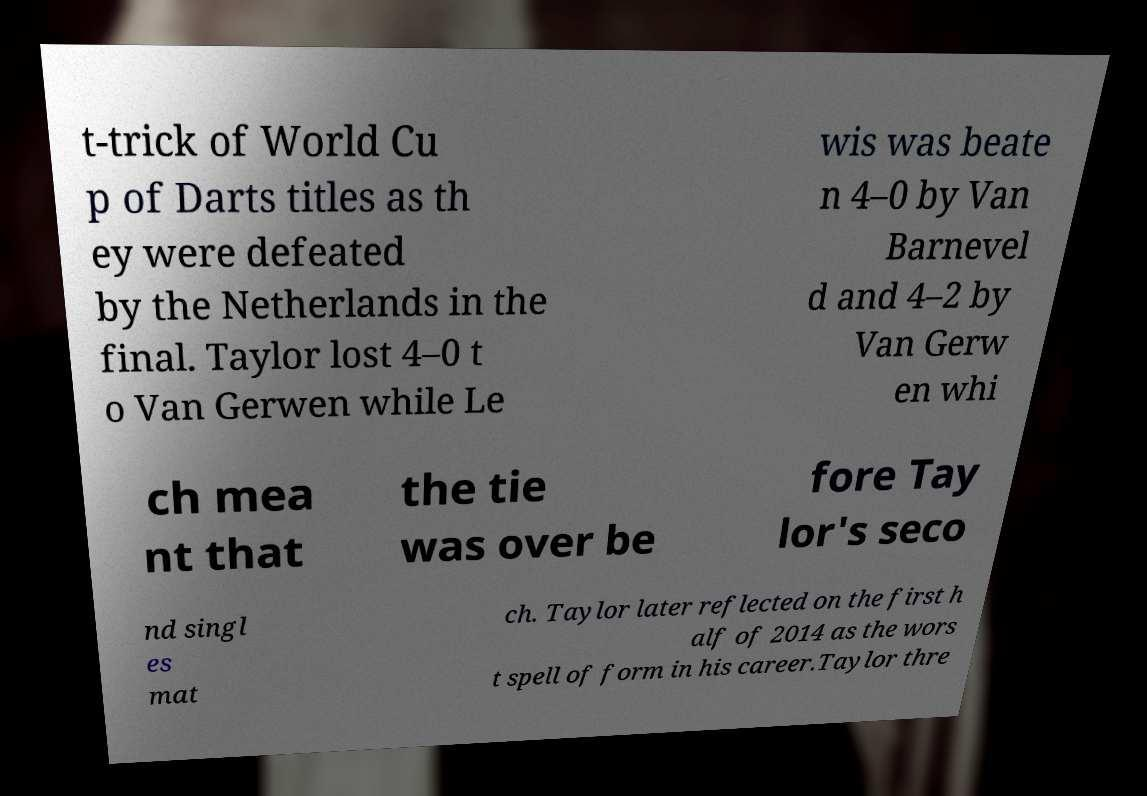What messages or text are displayed in this image? I need them in a readable, typed format. t-trick of World Cu p of Darts titles as th ey were defeated by the Netherlands in the final. Taylor lost 4–0 t o Van Gerwen while Le wis was beate n 4–0 by Van Barnevel d and 4–2 by Van Gerw en whi ch mea nt that the tie was over be fore Tay lor's seco nd singl es mat ch. Taylor later reflected on the first h alf of 2014 as the wors t spell of form in his career.Taylor thre 